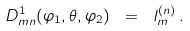Convert formula to latex. <formula><loc_0><loc_0><loc_500><loc_500>D ^ { 1 } _ { m n } ( \varphi _ { 1 } , \theta , \varphi _ { 2 } ) \ = \ l ^ { ( n ) } _ { m } \, .</formula> 